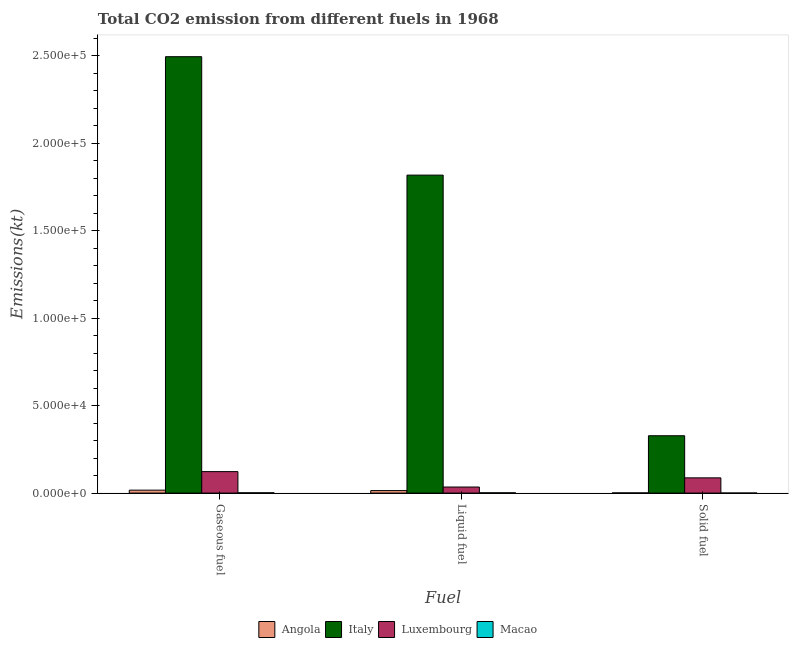How many groups of bars are there?
Offer a terse response. 3. Are the number of bars on each tick of the X-axis equal?
Give a very brief answer. Yes. How many bars are there on the 3rd tick from the left?
Provide a short and direct response. 4. What is the label of the 2nd group of bars from the left?
Ensure brevity in your answer.  Liquid fuel. What is the amount of co2 emissions from liquid fuel in Luxembourg?
Your response must be concise. 3461.65. Across all countries, what is the maximum amount of co2 emissions from solid fuel?
Keep it short and to the point. 3.28e+04. Across all countries, what is the minimum amount of co2 emissions from liquid fuel?
Provide a succinct answer. 157.68. In which country was the amount of co2 emissions from solid fuel minimum?
Ensure brevity in your answer.  Macao. What is the total amount of co2 emissions from liquid fuel in the graph?
Offer a very short reply. 1.87e+05. What is the difference between the amount of co2 emissions from liquid fuel in Angola and that in Luxembourg?
Offer a terse response. -2042.52. What is the difference between the amount of co2 emissions from gaseous fuel in Macao and the amount of co2 emissions from liquid fuel in Italy?
Offer a very short reply. -1.82e+05. What is the average amount of co2 emissions from liquid fuel per country?
Provide a succinct answer. 4.67e+04. What is the difference between the amount of co2 emissions from solid fuel and amount of co2 emissions from gaseous fuel in Angola?
Offer a very short reply. -1569.48. What is the ratio of the amount of co2 emissions from liquid fuel in Italy to that in Angola?
Make the answer very short. 128.1. Is the difference between the amount of co2 emissions from gaseous fuel in Luxembourg and Angola greater than the difference between the amount of co2 emissions from solid fuel in Luxembourg and Angola?
Your answer should be very brief. Yes. What is the difference between the highest and the second highest amount of co2 emissions from gaseous fuel?
Your answer should be very brief. 2.37e+05. What is the difference between the highest and the lowest amount of co2 emissions from solid fuel?
Provide a short and direct response. 3.28e+04. Is the sum of the amount of co2 emissions from gaseous fuel in Angola and Italy greater than the maximum amount of co2 emissions from liquid fuel across all countries?
Offer a very short reply. Yes. What does the 1st bar from the left in Gaseous fuel represents?
Your response must be concise. Angola. What does the 3rd bar from the right in Gaseous fuel represents?
Your answer should be very brief. Italy. How many bars are there?
Your answer should be very brief. 12. How many countries are there in the graph?
Ensure brevity in your answer.  4. What is the difference between two consecutive major ticks on the Y-axis?
Provide a succinct answer. 5.00e+04. Are the values on the major ticks of Y-axis written in scientific E-notation?
Make the answer very short. Yes. Does the graph contain grids?
Make the answer very short. No. How are the legend labels stacked?
Ensure brevity in your answer.  Horizontal. What is the title of the graph?
Keep it short and to the point. Total CO2 emission from different fuels in 1968. Does "Sweden" appear as one of the legend labels in the graph?
Offer a very short reply. No. What is the label or title of the X-axis?
Provide a succinct answer. Fuel. What is the label or title of the Y-axis?
Give a very brief answer. Emissions(kt). What is the Emissions(kt) in Angola in Gaseous fuel?
Your answer should be very brief. 1672.15. What is the Emissions(kt) in Italy in Gaseous fuel?
Offer a very short reply. 2.49e+05. What is the Emissions(kt) of Luxembourg in Gaseous fuel?
Provide a short and direct response. 1.23e+04. What is the Emissions(kt) of Macao in Gaseous fuel?
Offer a very short reply. 168.68. What is the Emissions(kt) in Angola in Liquid fuel?
Keep it short and to the point. 1419.13. What is the Emissions(kt) in Italy in Liquid fuel?
Ensure brevity in your answer.  1.82e+05. What is the Emissions(kt) of Luxembourg in Liquid fuel?
Keep it short and to the point. 3461.65. What is the Emissions(kt) in Macao in Liquid fuel?
Your response must be concise. 157.68. What is the Emissions(kt) in Angola in Solid fuel?
Provide a succinct answer. 102.68. What is the Emissions(kt) in Italy in Solid fuel?
Provide a succinct answer. 3.28e+04. What is the Emissions(kt) of Luxembourg in Solid fuel?
Your response must be concise. 8705.46. What is the Emissions(kt) in Macao in Solid fuel?
Your answer should be very brief. 11. Across all Fuel, what is the maximum Emissions(kt) of Angola?
Your response must be concise. 1672.15. Across all Fuel, what is the maximum Emissions(kt) in Italy?
Offer a terse response. 2.49e+05. Across all Fuel, what is the maximum Emissions(kt) of Luxembourg?
Your response must be concise. 1.23e+04. Across all Fuel, what is the maximum Emissions(kt) in Macao?
Provide a succinct answer. 168.68. Across all Fuel, what is the minimum Emissions(kt) in Angola?
Your response must be concise. 102.68. Across all Fuel, what is the minimum Emissions(kt) of Italy?
Provide a succinct answer. 3.28e+04. Across all Fuel, what is the minimum Emissions(kt) in Luxembourg?
Offer a terse response. 3461.65. Across all Fuel, what is the minimum Emissions(kt) in Macao?
Ensure brevity in your answer.  11. What is the total Emissions(kt) of Angola in the graph?
Your answer should be very brief. 3193.96. What is the total Emissions(kt) of Italy in the graph?
Your answer should be very brief. 4.64e+05. What is the total Emissions(kt) of Luxembourg in the graph?
Your response must be concise. 2.44e+04. What is the total Emissions(kt) of Macao in the graph?
Your answer should be compact. 337.36. What is the difference between the Emissions(kt) of Angola in Gaseous fuel and that in Liquid fuel?
Your answer should be compact. 253.02. What is the difference between the Emissions(kt) of Italy in Gaseous fuel and that in Liquid fuel?
Provide a short and direct response. 6.77e+04. What is the difference between the Emissions(kt) in Luxembourg in Gaseous fuel and that in Liquid fuel?
Your answer should be very brief. 8808.13. What is the difference between the Emissions(kt) in Macao in Gaseous fuel and that in Liquid fuel?
Ensure brevity in your answer.  11. What is the difference between the Emissions(kt) in Angola in Gaseous fuel and that in Solid fuel?
Offer a terse response. 1569.48. What is the difference between the Emissions(kt) in Italy in Gaseous fuel and that in Solid fuel?
Provide a succinct answer. 2.17e+05. What is the difference between the Emissions(kt) of Luxembourg in Gaseous fuel and that in Solid fuel?
Your answer should be very brief. 3564.32. What is the difference between the Emissions(kt) of Macao in Gaseous fuel and that in Solid fuel?
Offer a very short reply. 157.68. What is the difference between the Emissions(kt) of Angola in Liquid fuel and that in Solid fuel?
Offer a very short reply. 1316.45. What is the difference between the Emissions(kt) in Italy in Liquid fuel and that in Solid fuel?
Make the answer very short. 1.49e+05. What is the difference between the Emissions(kt) of Luxembourg in Liquid fuel and that in Solid fuel?
Provide a succinct answer. -5243.81. What is the difference between the Emissions(kt) in Macao in Liquid fuel and that in Solid fuel?
Provide a succinct answer. 146.68. What is the difference between the Emissions(kt) of Angola in Gaseous fuel and the Emissions(kt) of Italy in Liquid fuel?
Ensure brevity in your answer.  -1.80e+05. What is the difference between the Emissions(kt) of Angola in Gaseous fuel and the Emissions(kt) of Luxembourg in Liquid fuel?
Offer a terse response. -1789.5. What is the difference between the Emissions(kt) of Angola in Gaseous fuel and the Emissions(kt) of Macao in Liquid fuel?
Keep it short and to the point. 1514.47. What is the difference between the Emissions(kt) in Italy in Gaseous fuel and the Emissions(kt) in Luxembourg in Liquid fuel?
Ensure brevity in your answer.  2.46e+05. What is the difference between the Emissions(kt) in Italy in Gaseous fuel and the Emissions(kt) in Macao in Liquid fuel?
Make the answer very short. 2.49e+05. What is the difference between the Emissions(kt) of Luxembourg in Gaseous fuel and the Emissions(kt) of Macao in Liquid fuel?
Your response must be concise. 1.21e+04. What is the difference between the Emissions(kt) of Angola in Gaseous fuel and the Emissions(kt) of Italy in Solid fuel?
Provide a succinct answer. -3.11e+04. What is the difference between the Emissions(kt) of Angola in Gaseous fuel and the Emissions(kt) of Luxembourg in Solid fuel?
Provide a short and direct response. -7033.31. What is the difference between the Emissions(kt) in Angola in Gaseous fuel and the Emissions(kt) in Macao in Solid fuel?
Provide a succinct answer. 1661.15. What is the difference between the Emissions(kt) in Italy in Gaseous fuel and the Emissions(kt) in Luxembourg in Solid fuel?
Provide a short and direct response. 2.41e+05. What is the difference between the Emissions(kt) in Italy in Gaseous fuel and the Emissions(kt) in Macao in Solid fuel?
Provide a succinct answer. 2.49e+05. What is the difference between the Emissions(kt) in Luxembourg in Gaseous fuel and the Emissions(kt) in Macao in Solid fuel?
Provide a succinct answer. 1.23e+04. What is the difference between the Emissions(kt) of Angola in Liquid fuel and the Emissions(kt) of Italy in Solid fuel?
Offer a terse response. -3.14e+04. What is the difference between the Emissions(kt) in Angola in Liquid fuel and the Emissions(kt) in Luxembourg in Solid fuel?
Make the answer very short. -7286.33. What is the difference between the Emissions(kt) in Angola in Liquid fuel and the Emissions(kt) in Macao in Solid fuel?
Your answer should be very brief. 1408.13. What is the difference between the Emissions(kt) in Italy in Liquid fuel and the Emissions(kt) in Luxembourg in Solid fuel?
Offer a terse response. 1.73e+05. What is the difference between the Emissions(kt) of Italy in Liquid fuel and the Emissions(kt) of Macao in Solid fuel?
Ensure brevity in your answer.  1.82e+05. What is the difference between the Emissions(kt) in Luxembourg in Liquid fuel and the Emissions(kt) in Macao in Solid fuel?
Your answer should be compact. 3450.65. What is the average Emissions(kt) of Angola per Fuel?
Make the answer very short. 1064.65. What is the average Emissions(kt) in Italy per Fuel?
Your answer should be very brief. 1.55e+05. What is the average Emissions(kt) of Luxembourg per Fuel?
Your response must be concise. 8145.63. What is the average Emissions(kt) in Macao per Fuel?
Provide a succinct answer. 112.45. What is the difference between the Emissions(kt) of Angola and Emissions(kt) of Italy in Gaseous fuel?
Your answer should be very brief. -2.48e+05. What is the difference between the Emissions(kt) of Angola and Emissions(kt) of Luxembourg in Gaseous fuel?
Keep it short and to the point. -1.06e+04. What is the difference between the Emissions(kt) of Angola and Emissions(kt) of Macao in Gaseous fuel?
Offer a very short reply. 1503.47. What is the difference between the Emissions(kt) in Italy and Emissions(kt) in Luxembourg in Gaseous fuel?
Your answer should be very brief. 2.37e+05. What is the difference between the Emissions(kt) in Italy and Emissions(kt) in Macao in Gaseous fuel?
Your answer should be compact. 2.49e+05. What is the difference between the Emissions(kt) in Luxembourg and Emissions(kt) in Macao in Gaseous fuel?
Make the answer very short. 1.21e+04. What is the difference between the Emissions(kt) of Angola and Emissions(kt) of Italy in Liquid fuel?
Give a very brief answer. -1.80e+05. What is the difference between the Emissions(kt) of Angola and Emissions(kt) of Luxembourg in Liquid fuel?
Your response must be concise. -2042.52. What is the difference between the Emissions(kt) of Angola and Emissions(kt) of Macao in Liquid fuel?
Offer a terse response. 1261.45. What is the difference between the Emissions(kt) in Italy and Emissions(kt) in Luxembourg in Liquid fuel?
Provide a succinct answer. 1.78e+05. What is the difference between the Emissions(kt) of Italy and Emissions(kt) of Macao in Liquid fuel?
Ensure brevity in your answer.  1.82e+05. What is the difference between the Emissions(kt) in Luxembourg and Emissions(kt) in Macao in Liquid fuel?
Make the answer very short. 3303.97. What is the difference between the Emissions(kt) of Angola and Emissions(kt) of Italy in Solid fuel?
Your response must be concise. -3.27e+04. What is the difference between the Emissions(kt) of Angola and Emissions(kt) of Luxembourg in Solid fuel?
Ensure brevity in your answer.  -8602.78. What is the difference between the Emissions(kt) in Angola and Emissions(kt) in Macao in Solid fuel?
Keep it short and to the point. 91.67. What is the difference between the Emissions(kt) of Italy and Emissions(kt) of Luxembourg in Solid fuel?
Give a very brief answer. 2.41e+04. What is the difference between the Emissions(kt) in Italy and Emissions(kt) in Macao in Solid fuel?
Your answer should be compact. 3.28e+04. What is the difference between the Emissions(kt) of Luxembourg and Emissions(kt) of Macao in Solid fuel?
Give a very brief answer. 8694.46. What is the ratio of the Emissions(kt) of Angola in Gaseous fuel to that in Liquid fuel?
Your response must be concise. 1.18. What is the ratio of the Emissions(kt) in Italy in Gaseous fuel to that in Liquid fuel?
Offer a terse response. 1.37. What is the ratio of the Emissions(kt) in Luxembourg in Gaseous fuel to that in Liquid fuel?
Offer a very short reply. 3.54. What is the ratio of the Emissions(kt) in Macao in Gaseous fuel to that in Liquid fuel?
Provide a succinct answer. 1.07. What is the ratio of the Emissions(kt) in Angola in Gaseous fuel to that in Solid fuel?
Provide a short and direct response. 16.29. What is the ratio of the Emissions(kt) in Italy in Gaseous fuel to that in Solid fuel?
Your answer should be compact. 7.61. What is the ratio of the Emissions(kt) of Luxembourg in Gaseous fuel to that in Solid fuel?
Give a very brief answer. 1.41. What is the ratio of the Emissions(kt) of Macao in Gaseous fuel to that in Solid fuel?
Your answer should be compact. 15.33. What is the ratio of the Emissions(kt) of Angola in Liquid fuel to that in Solid fuel?
Make the answer very short. 13.82. What is the ratio of the Emissions(kt) of Italy in Liquid fuel to that in Solid fuel?
Offer a very short reply. 5.55. What is the ratio of the Emissions(kt) of Luxembourg in Liquid fuel to that in Solid fuel?
Your answer should be compact. 0.4. What is the ratio of the Emissions(kt) of Macao in Liquid fuel to that in Solid fuel?
Make the answer very short. 14.33. What is the difference between the highest and the second highest Emissions(kt) in Angola?
Offer a terse response. 253.02. What is the difference between the highest and the second highest Emissions(kt) of Italy?
Your response must be concise. 6.77e+04. What is the difference between the highest and the second highest Emissions(kt) of Luxembourg?
Your response must be concise. 3564.32. What is the difference between the highest and the second highest Emissions(kt) of Macao?
Offer a terse response. 11. What is the difference between the highest and the lowest Emissions(kt) in Angola?
Your answer should be compact. 1569.48. What is the difference between the highest and the lowest Emissions(kt) of Italy?
Ensure brevity in your answer.  2.17e+05. What is the difference between the highest and the lowest Emissions(kt) of Luxembourg?
Provide a short and direct response. 8808.13. What is the difference between the highest and the lowest Emissions(kt) of Macao?
Your response must be concise. 157.68. 